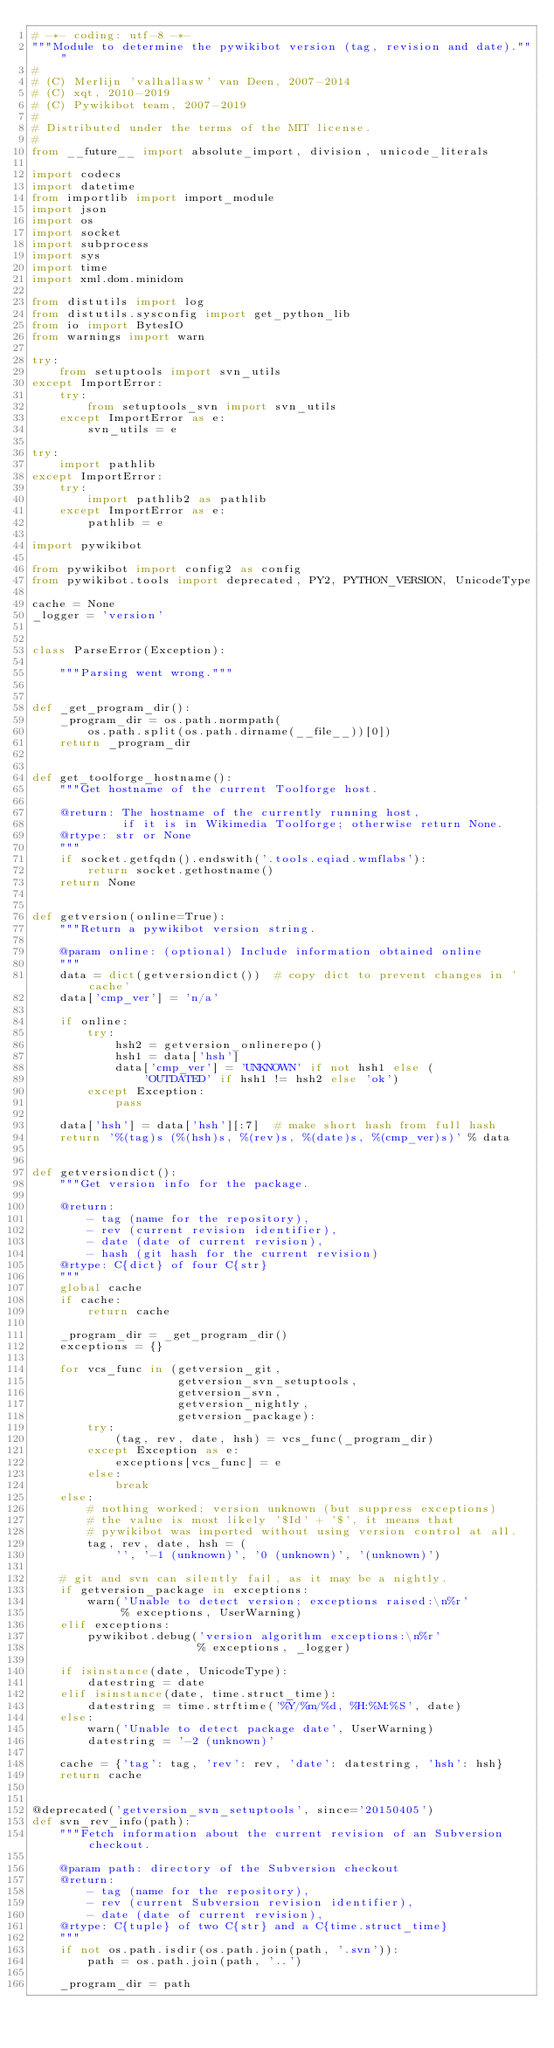<code> <loc_0><loc_0><loc_500><loc_500><_Python_># -*- coding: utf-8 -*-
"""Module to determine the pywikibot version (tag, revision and date)."""
#
# (C) Merlijn 'valhallasw' van Deen, 2007-2014
# (C) xqt, 2010-2019
# (C) Pywikibot team, 2007-2019
#
# Distributed under the terms of the MIT license.
#
from __future__ import absolute_import, division, unicode_literals

import codecs
import datetime
from importlib import import_module
import json
import os
import socket
import subprocess
import sys
import time
import xml.dom.minidom

from distutils import log
from distutils.sysconfig import get_python_lib
from io import BytesIO
from warnings import warn

try:
    from setuptools import svn_utils
except ImportError:
    try:
        from setuptools_svn import svn_utils
    except ImportError as e:
        svn_utils = e

try:
    import pathlib
except ImportError:
    try:
        import pathlib2 as pathlib
    except ImportError as e:
        pathlib = e

import pywikibot

from pywikibot import config2 as config
from pywikibot.tools import deprecated, PY2, PYTHON_VERSION, UnicodeType

cache = None
_logger = 'version'


class ParseError(Exception):

    """Parsing went wrong."""


def _get_program_dir():
    _program_dir = os.path.normpath(
        os.path.split(os.path.dirname(__file__))[0])
    return _program_dir


def get_toolforge_hostname():
    """Get hostname of the current Toolforge host.

    @return: The hostname of the currently running host,
             if it is in Wikimedia Toolforge; otherwise return None.
    @rtype: str or None
    """
    if socket.getfqdn().endswith('.tools.eqiad.wmflabs'):
        return socket.gethostname()
    return None


def getversion(online=True):
    """Return a pywikibot version string.

    @param online: (optional) Include information obtained online
    """
    data = dict(getversiondict())  # copy dict to prevent changes in 'cache'
    data['cmp_ver'] = 'n/a'

    if online:
        try:
            hsh2 = getversion_onlinerepo()
            hsh1 = data['hsh']
            data['cmp_ver'] = 'UNKNOWN' if not hsh1 else (
                'OUTDATED' if hsh1 != hsh2 else 'ok')
        except Exception:
            pass

    data['hsh'] = data['hsh'][:7]  # make short hash from full hash
    return '%(tag)s (%(hsh)s, %(rev)s, %(date)s, %(cmp_ver)s)' % data


def getversiondict():
    """Get version info for the package.

    @return:
        - tag (name for the repository),
        - rev (current revision identifier),
        - date (date of current revision),
        - hash (git hash for the current revision)
    @rtype: C{dict} of four C{str}
    """
    global cache
    if cache:
        return cache

    _program_dir = _get_program_dir()
    exceptions = {}

    for vcs_func in (getversion_git,
                     getversion_svn_setuptools,
                     getversion_svn,
                     getversion_nightly,
                     getversion_package):
        try:
            (tag, rev, date, hsh) = vcs_func(_program_dir)
        except Exception as e:
            exceptions[vcs_func] = e
        else:
            break
    else:
        # nothing worked; version unknown (but suppress exceptions)
        # the value is most likely '$Id' + '$', it means that
        # pywikibot was imported without using version control at all.
        tag, rev, date, hsh = (
            '', '-1 (unknown)', '0 (unknown)', '(unknown)')

    # git and svn can silently fail, as it may be a nightly.
    if getversion_package in exceptions:
        warn('Unable to detect version; exceptions raised:\n%r'
             % exceptions, UserWarning)
    elif exceptions:
        pywikibot.debug('version algorithm exceptions:\n%r'
                        % exceptions, _logger)

    if isinstance(date, UnicodeType):
        datestring = date
    elif isinstance(date, time.struct_time):
        datestring = time.strftime('%Y/%m/%d, %H:%M:%S', date)
    else:
        warn('Unable to detect package date', UserWarning)
        datestring = '-2 (unknown)'

    cache = {'tag': tag, 'rev': rev, 'date': datestring, 'hsh': hsh}
    return cache


@deprecated('getversion_svn_setuptools', since='20150405')
def svn_rev_info(path):
    """Fetch information about the current revision of an Subversion checkout.

    @param path: directory of the Subversion checkout
    @return:
        - tag (name for the repository),
        - rev (current Subversion revision identifier),
        - date (date of current revision),
    @rtype: C{tuple} of two C{str} and a C{time.struct_time}
    """
    if not os.path.isdir(os.path.join(path, '.svn')):
        path = os.path.join(path, '..')

    _program_dir = path</code> 